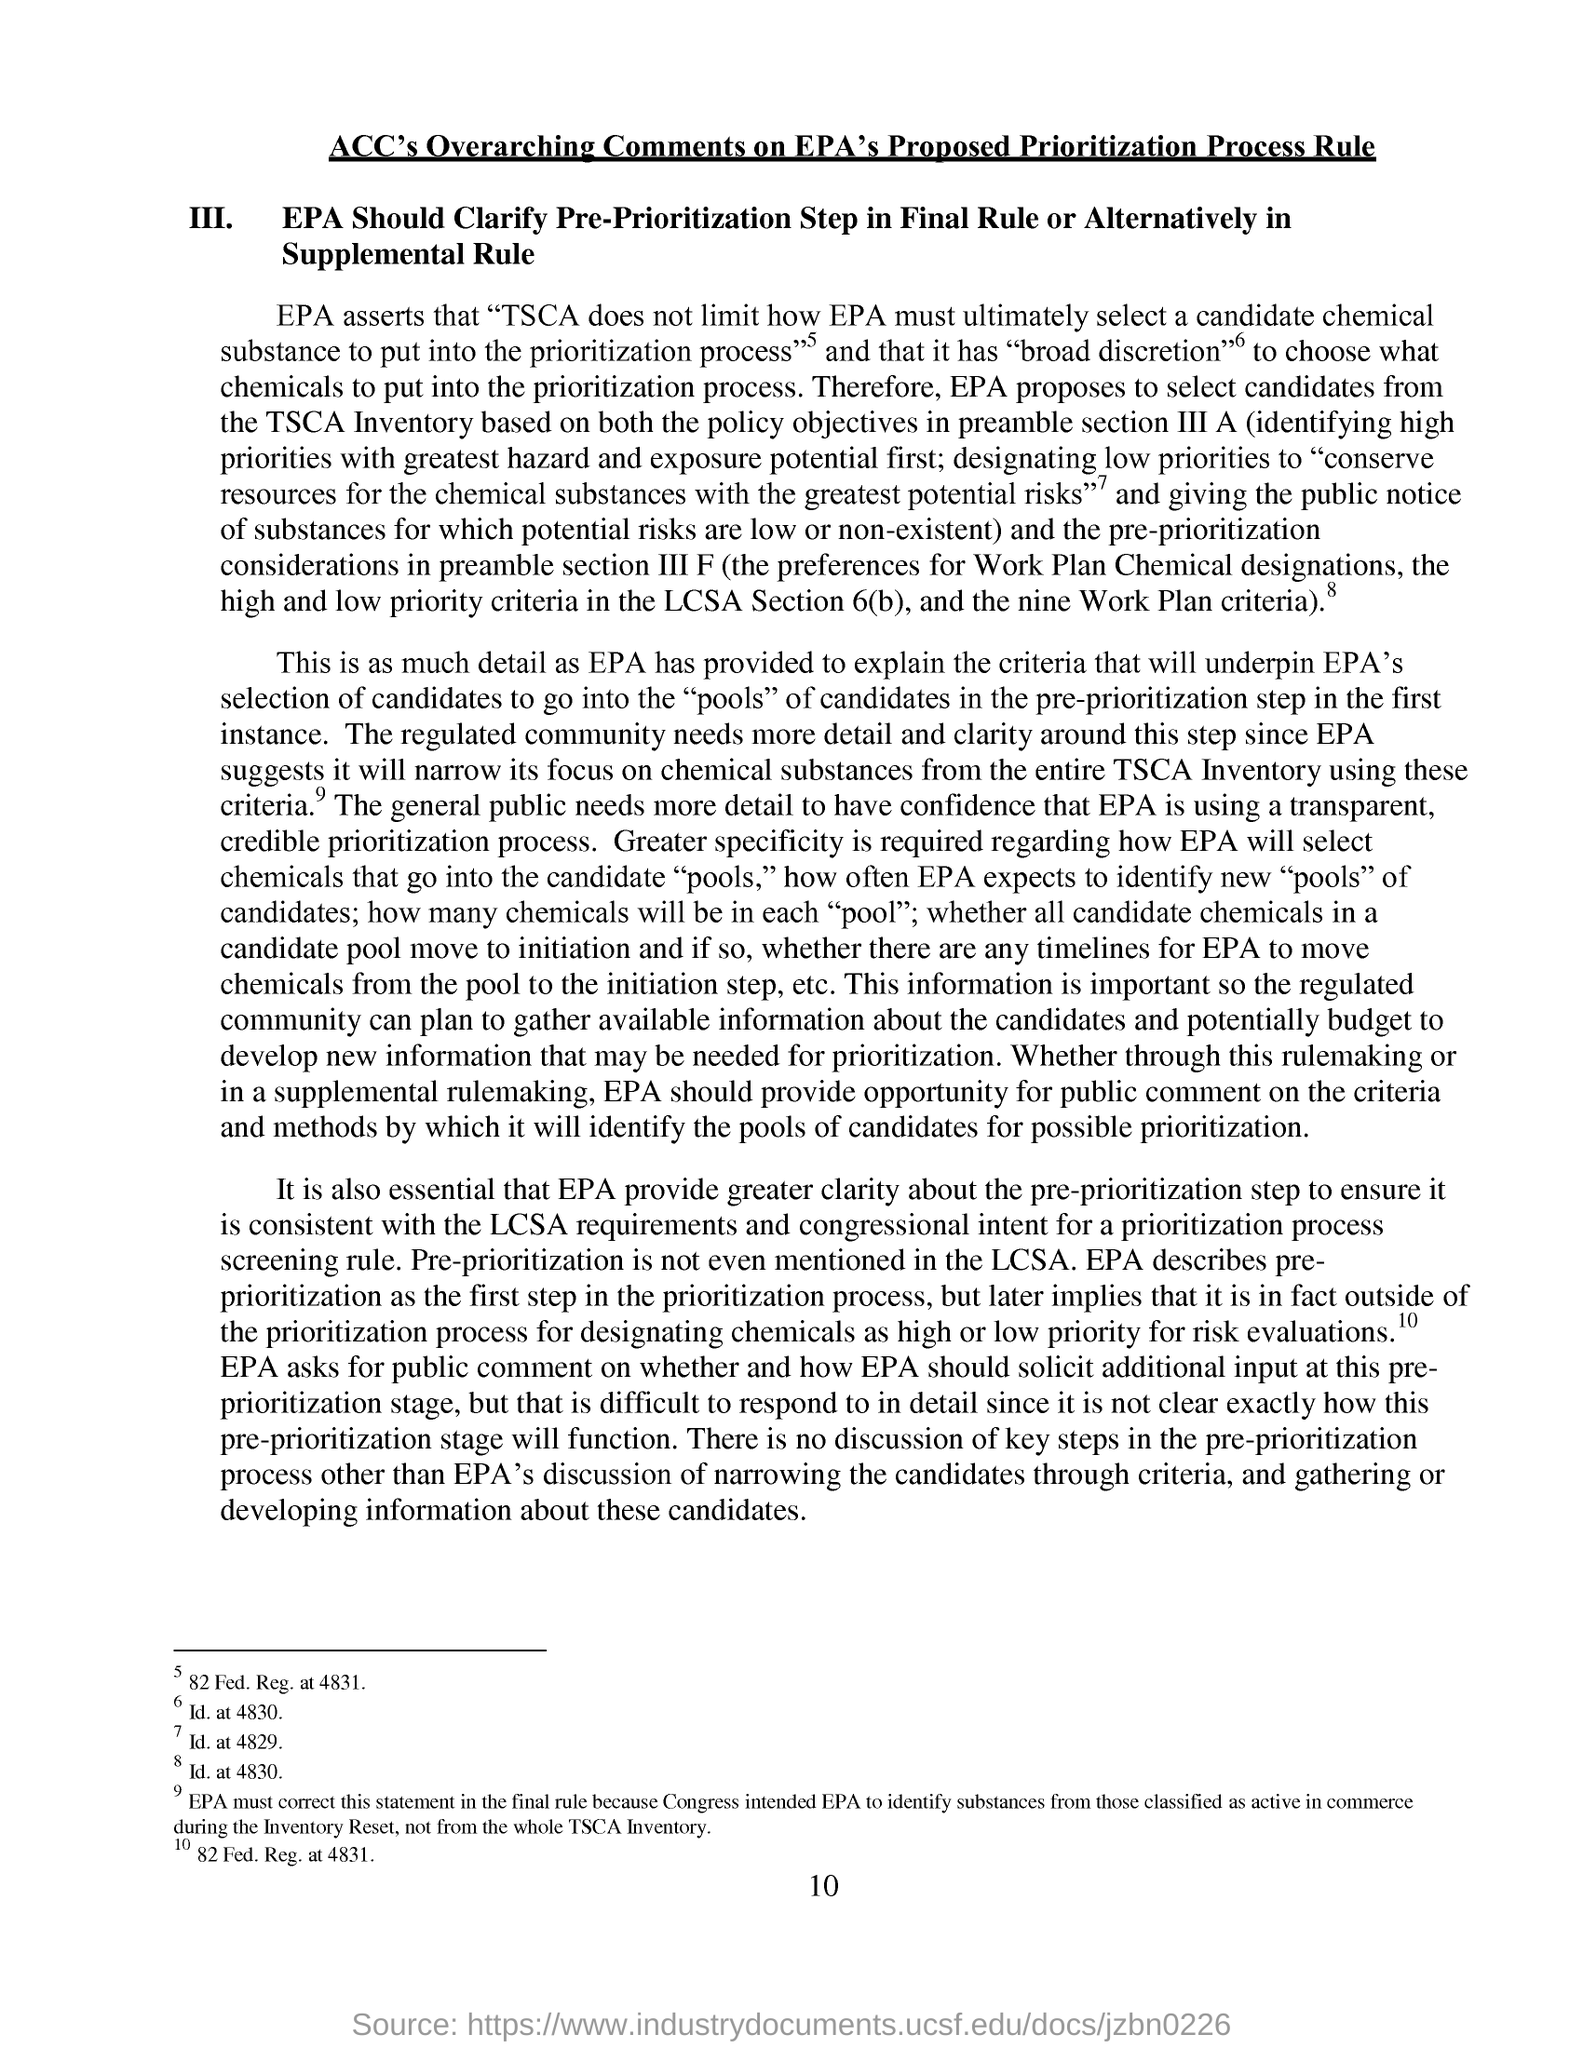Mention a couple of crucial points in this snapshot. The page number mentioned in this document is 10. 